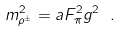Convert formula to latex. <formula><loc_0><loc_0><loc_500><loc_500>m _ { \rho ^ { \pm } } ^ { 2 } = a F _ { \pi } ^ { 2 } g ^ { 2 } \ .</formula> 